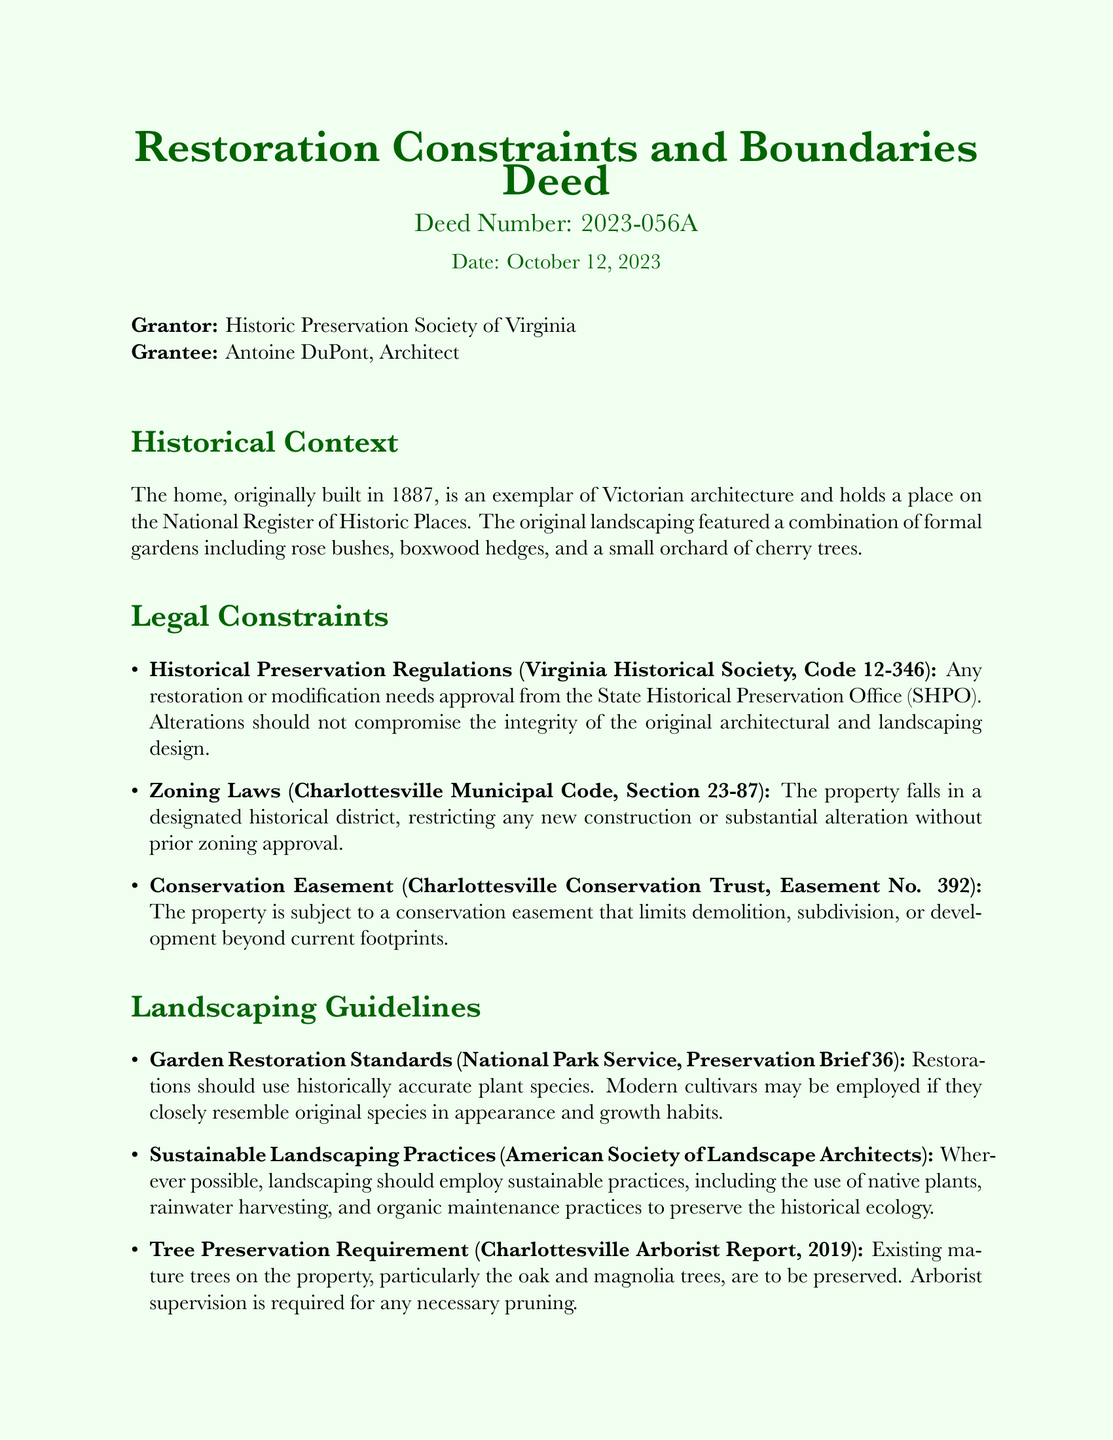What is the deed number? The deed number is a unique identifier for the document, which is noted on the header.
Answer: 2023-056A Who is the grantor of the deed? The grantor is the entity transferring interests or rights, as stated in the deed.
Answer: Historic Preservation Society of Virginia When was the deed issued? The date of issuance is prominently displayed in the document.
Answer: October 12, 2023 What year was the home originally built? The year the home was constructed is provided in the historical context section.
Answer: 1887 What is the primary architectural style of the home? The architectural style is indicated in the historical context section of the deed.
Answer: Victorian What organization must approve any restoration or modification? This organization is essential for historical preservation and is listed in the legal constraints.
Answer: State Historical Preservation Office (SHPO) What type of trees must be preserved according to the guidelines? This requirement highlights what vegetation is protected, as articulated in the landscaping guidelines.
Answer: Oak and magnolia trees What is required for professional supervision of the project? This requirement is crucial for ensuring compliance with standards, and is specified in the notable clauses.
Answer: A certified historical architecture specialist What landscaping practice is encouraged in the guidelines? This practice aims to support ecological and historical integrity, as emphasized in the document.
Answer: Sustainable practices 